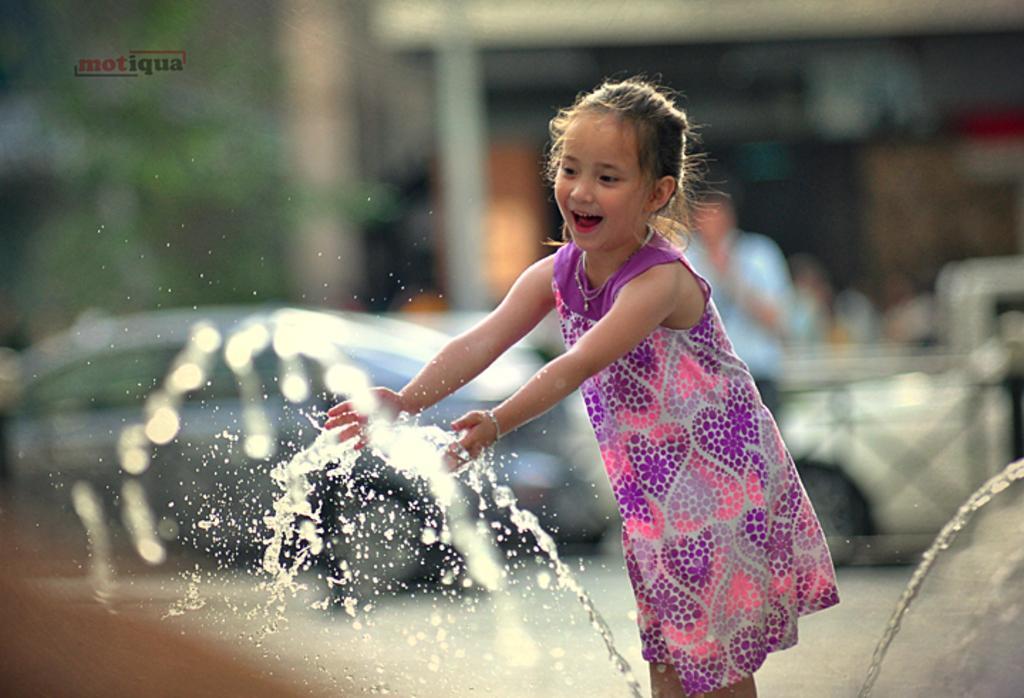In one or two sentences, can you explain what this image depicts? In this image I can see a girl is standing and in the front of her I can see water. In the background I can see few vehicles, one person, a tree and I can see this image is little bit blurry in the background. On the top left side of this image I can see a watermark. 